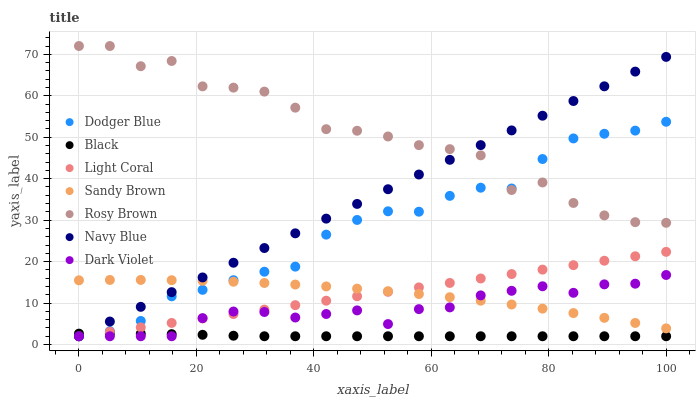Does Black have the minimum area under the curve?
Answer yes or no. Yes. Does Rosy Brown have the maximum area under the curve?
Answer yes or no. Yes. Does Dark Violet have the minimum area under the curve?
Answer yes or no. No. Does Dark Violet have the maximum area under the curve?
Answer yes or no. No. Is Light Coral the smoothest?
Answer yes or no. Yes. Is Rosy Brown the roughest?
Answer yes or no. Yes. Is Dark Violet the smoothest?
Answer yes or no. No. Is Dark Violet the roughest?
Answer yes or no. No. Does Navy Blue have the lowest value?
Answer yes or no. Yes. Does Rosy Brown have the lowest value?
Answer yes or no. No. Does Rosy Brown have the highest value?
Answer yes or no. Yes. Does Dark Violet have the highest value?
Answer yes or no. No. Is Dark Violet less than Rosy Brown?
Answer yes or no. Yes. Is Rosy Brown greater than Sandy Brown?
Answer yes or no. Yes. Does Light Coral intersect Black?
Answer yes or no. Yes. Is Light Coral less than Black?
Answer yes or no. No. Is Light Coral greater than Black?
Answer yes or no. No. Does Dark Violet intersect Rosy Brown?
Answer yes or no. No. 